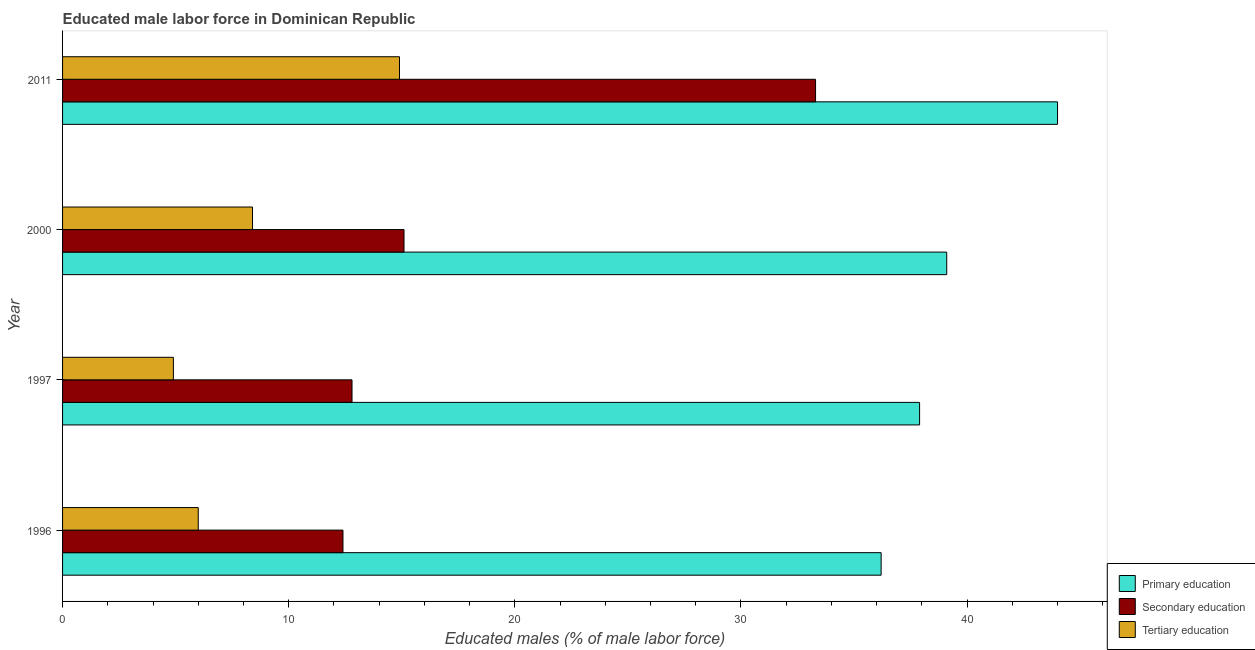How many bars are there on the 1st tick from the top?
Make the answer very short. 3. How many bars are there on the 2nd tick from the bottom?
Offer a terse response. 3. What is the label of the 4th group of bars from the top?
Give a very brief answer. 1996. What is the percentage of male labor force who received primary education in 2011?
Provide a succinct answer. 44. Across all years, what is the minimum percentage of male labor force who received tertiary education?
Ensure brevity in your answer.  4.9. In which year was the percentage of male labor force who received secondary education maximum?
Ensure brevity in your answer.  2011. What is the total percentage of male labor force who received tertiary education in the graph?
Offer a terse response. 34.2. What is the difference between the percentage of male labor force who received secondary education in 1996 and that in 1997?
Provide a succinct answer. -0.4. What is the difference between the percentage of male labor force who received primary education in 1997 and the percentage of male labor force who received tertiary education in 2011?
Provide a short and direct response. 23. In the year 2011, what is the difference between the percentage of male labor force who received secondary education and percentage of male labor force who received primary education?
Your answer should be compact. -10.7. In how many years, is the percentage of male labor force who received primary education greater than 8 %?
Provide a short and direct response. 4. What is the ratio of the percentage of male labor force who received secondary education in 1996 to that in 2011?
Your answer should be compact. 0.37. Is the percentage of male labor force who received primary education in 1996 less than that in 2011?
Your response must be concise. Yes. Is the difference between the percentage of male labor force who received primary education in 1997 and 2000 greater than the difference between the percentage of male labor force who received secondary education in 1997 and 2000?
Give a very brief answer. Yes. What is the difference between the highest and the lowest percentage of male labor force who received tertiary education?
Your response must be concise. 10. In how many years, is the percentage of male labor force who received primary education greater than the average percentage of male labor force who received primary education taken over all years?
Your response must be concise. 1. What does the 3rd bar from the top in 2011 represents?
Offer a very short reply. Primary education. What does the 3rd bar from the bottom in 1997 represents?
Offer a terse response. Tertiary education. How many years are there in the graph?
Provide a succinct answer. 4. What is the difference between two consecutive major ticks on the X-axis?
Your answer should be very brief. 10. Does the graph contain any zero values?
Provide a succinct answer. No. How are the legend labels stacked?
Offer a terse response. Vertical. What is the title of the graph?
Provide a short and direct response. Educated male labor force in Dominican Republic. What is the label or title of the X-axis?
Provide a short and direct response. Educated males (% of male labor force). What is the label or title of the Y-axis?
Give a very brief answer. Year. What is the Educated males (% of male labor force) of Primary education in 1996?
Give a very brief answer. 36.2. What is the Educated males (% of male labor force) in Secondary education in 1996?
Your answer should be compact. 12.4. What is the Educated males (% of male labor force) of Primary education in 1997?
Provide a short and direct response. 37.9. What is the Educated males (% of male labor force) of Secondary education in 1997?
Your answer should be very brief. 12.8. What is the Educated males (% of male labor force) of Tertiary education in 1997?
Offer a terse response. 4.9. What is the Educated males (% of male labor force) of Primary education in 2000?
Your answer should be very brief. 39.1. What is the Educated males (% of male labor force) in Secondary education in 2000?
Provide a short and direct response. 15.1. What is the Educated males (% of male labor force) of Tertiary education in 2000?
Provide a short and direct response. 8.4. What is the Educated males (% of male labor force) of Primary education in 2011?
Your answer should be compact. 44. What is the Educated males (% of male labor force) of Secondary education in 2011?
Your response must be concise. 33.3. What is the Educated males (% of male labor force) of Tertiary education in 2011?
Make the answer very short. 14.9. Across all years, what is the maximum Educated males (% of male labor force) of Primary education?
Your response must be concise. 44. Across all years, what is the maximum Educated males (% of male labor force) in Secondary education?
Your answer should be compact. 33.3. Across all years, what is the maximum Educated males (% of male labor force) in Tertiary education?
Your response must be concise. 14.9. Across all years, what is the minimum Educated males (% of male labor force) of Primary education?
Give a very brief answer. 36.2. Across all years, what is the minimum Educated males (% of male labor force) of Secondary education?
Provide a succinct answer. 12.4. Across all years, what is the minimum Educated males (% of male labor force) in Tertiary education?
Provide a succinct answer. 4.9. What is the total Educated males (% of male labor force) in Primary education in the graph?
Make the answer very short. 157.2. What is the total Educated males (% of male labor force) of Secondary education in the graph?
Provide a succinct answer. 73.6. What is the total Educated males (% of male labor force) of Tertiary education in the graph?
Offer a very short reply. 34.2. What is the difference between the Educated males (% of male labor force) in Secondary education in 1996 and that in 1997?
Your answer should be very brief. -0.4. What is the difference between the Educated males (% of male labor force) in Tertiary education in 1996 and that in 1997?
Offer a terse response. 1.1. What is the difference between the Educated males (% of male labor force) in Tertiary education in 1996 and that in 2000?
Offer a terse response. -2.4. What is the difference between the Educated males (% of male labor force) in Primary education in 1996 and that in 2011?
Keep it short and to the point. -7.8. What is the difference between the Educated males (% of male labor force) of Secondary education in 1996 and that in 2011?
Ensure brevity in your answer.  -20.9. What is the difference between the Educated males (% of male labor force) of Tertiary education in 1996 and that in 2011?
Provide a short and direct response. -8.9. What is the difference between the Educated males (% of male labor force) in Secondary education in 1997 and that in 2000?
Ensure brevity in your answer.  -2.3. What is the difference between the Educated males (% of male labor force) in Primary education in 1997 and that in 2011?
Offer a terse response. -6.1. What is the difference between the Educated males (% of male labor force) of Secondary education in 1997 and that in 2011?
Your response must be concise. -20.5. What is the difference between the Educated males (% of male labor force) in Secondary education in 2000 and that in 2011?
Your response must be concise. -18.2. What is the difference between the Educated males (% of male labor force) of Primary education in 1996 and the Educated males (% of male labor force) of Secondary education in 1997?
Make the answer very short. 23.4. What is the difference between the Educated males (% of male labor force) of Primary education in 1996 and the Educated males (% of male labor force) of Tertiary education in 1997?
Make the answer very short. 31.3. What is the difference between the Educated males (% of male labor force) in Secondary education in 1996 and the Educated males (% of male labor force) in Tertiary education in 1997?
Your answer should be very brief. 7.5. What is the difference between the Educated males (% of male labor force) in Primary education in 1996 and the Educated males (% of male labor force) in Secondary education in 2000?
Offer a very short reply. 21.1. What is the difference between the Educated males (% of male labor force) of Primary education in 1996 and the Educated males (% of male labor force) of Tertiary education in 2000?
Your answer should be very brief. 27.8. What is the difference between the Educated males (% of male labor force) in Secondary education in 1996 and the Educated males (% of male labor force) in Tertiary education in 2000?
Your answer should be very brief. 4. What is the difference between the Educated males (% of male labor force) of Primary education in 1996 and the Educated males (% of male labor force) of Secondary education in 2011?
Provide a short and direct response. 2.9. What is the difference between the Educated males (% of male labor force) in Primary education in 1996 and the Educated males (% of male labor force) in Tertiary education in 2011?
Offer a very short reply. 21.3. What is the difference between the Educated males (% of male labor force) in Primary education in 1997 and the Educated males (% of male labor force) in Secondary education in 2000?
Your answer should be compact. 22.8. What is the difference between the Educated males (% of male labor force) of Primary education in 1997 and the Educated males (% of male labor force) of Tertiary education in 2000?
Your answer should be compact. 29.5. What is the difference between the Educated males (% of male labor force) of Primary education in 1997 and the Educated males (% of male labor force) of Secondary education in 2011?
Ensure brevity in your answer.  4.6. What is the difference between the Educated males (% of male labor force) in Secondary education in 1997 and the Educated males (% of male labor force) in Tertiary education in 2011?
Provide a short and direct response. -2.1. What is the difference between the Educated males (% of male labor force) of Primary education in 2000 and the Educated males (% of male labor force) of Secondary education in 2011?
Provide a succinct answer. 5.8. What is the difference between the Educated males (% of male labor force) in Primary education in 2000 and the Educated males (% of male labor force) in Tertiary education in 2011?
Make the answer very short. 24.2. What is the difference between the Educated males (% of male labor force) of Secondary education in 2000 and the Educated males (% of male labor force) of Tertiary education in 2011?
Keep it short and to the point. 0.2. What is the average Educated males (% of male labor force) in Primary education per year?
Your response must be concise. 39.3. What is the average Educated males (% of male labor force) in Tertiary education per year?
Offer a very short reply. 8.55. In the year 1996, what is the difference between the Educated males (% of male labor force) of Primary education and Educated males (% of male labor force) of Secondary education?
Your answer should be very brief. 23.8. In the year 1996, what is the difference between the Educated males (% of male labor force) in Primary education and Educated males (% of male labor force) in Tertiary education?
Your response must be concise. 30.2. In the year 1996, what is the difference between the Educated males (% of male labor force) in Secondary education and Educated males (% of male labor force) in Tertiary education?
Keep it short and to the point. 6.4. In the year 1997, what is the difference between the Educated males (% of male labor force) of Primary education and Educated males (% of male labor force) of Secondary education?
Your answer should be very brief. 25.1. In the year 1997, what is the difference between the Educated males (% of male labor force) in Primary education and Educated males (% of male labor force) in Tertiary education?
Your answer should be very brief. 33. In the year 2000, what is the difference between the Educated males (% of male labor force) of Primary education and Educated males (% of male labor force) of Tertiary education?
Keep it short and to the point. 30.7. In the year 2011, what is the difference between the Educated males (% of male labor force) of Primary education and Educated males (% of male labor force) of Secondary education?
Make the answer very short. 10.7. In the year 2011, what is the difference between the Educated males (% of male labor force) of Primary education and Educated males (% of male labor force) of Tertiary education?
Keep it short and to the point. 29.1. In the year 2011, what is the difference between the Educated males (% of male labor force) of Secondary education and Educated males (% of male labor force) of Tertiary education?
Keep it short and to the point. 18.4. What is the ratio of the Educated males (% of male labor force) of Primary education in 1996 to that in 1997?
Offer a very short reply. 0.96. What is the ratio of the Educated males (% of male labor force) in Secondary education in 1996 to that in 1997?
Offer a very short reply. 0.97. What is the ratio of the Educated males (% of male labor force) of Tertiary education in 1996 to that in 1997?
Provide a succinct answer. 1.22. What is the ratio of the Educated males (% of male labor force) of Primary education in 1996 to that in 2000?
Ensure brevity in your answer.  0.93. What is the ratio of the Educated males (% of male labor force) of Secondary education in 1996 to that in 2000?
Offer a very short reply. 0.82. What is the ratio of the Educated males (% of male labor force) in Tertiary education in 1996 to that in 2000?
Provide a succinct answer. 0.71. What is the ratio of the Educated males (% of male labor force) of Primary education in 1996 to that in 2011?
Give a very brief answer. 0.82. What is the ratio of the Educated males (% of male labor force) in Secondary education in 1996 to that in 2011?
Make the answer very short. 0.37. What is the ratio of the Educated males (% of male labor force) in Tertiary education in 1996 to that in 2011?
Your answer should be very brief. 0.4. What is the ratio of the Educated males (% of male labor force) of Primary education in 1997 to that in 2000?
Offer a very short reply. 0.97. What is the ratio of the Educated males (% of male labor force) in Secondary education in 1997 to that in 2000?
Offer a terse response. 0.85. What is the ratio of the Educated males (% of male labor force) of Tertiary education in 1997 to that in 2000?
Provide a succinct answer. 0.58. What is the ratio of the Educated males (% of male labor force) in Primary education in 1997 to that in 2011?
Your answer should be very brief. 0.86. What is the ratio of the Educated males (% of male labor force) in Secondary education in 1997 to that in 2011?
Provide a succinct answer. 0.38. What is the ratio of the Educated males (% of male labor force) in Tertiary education in 1997 to that in 2011?
Offer a terse response. 0.33. What is the ratio of the Educated males (% of male labor force) of Primary education in 2000 to that in 2011?
Your response must be concise. 0.89. What is the ratio of the Educated males (% of male labor force) of Secondary education in 2000 to that in 2011?
Keep it short and to the point. 0.45. What is the ratio of the Educated males (% of male labor force) of Tertiary education in 2000 to that in 2011?
Give a very brief answer. 0.56. What is the difference between the highest and the second highest Educated males (% of male labor force) of Tertiary education?
Offer a terse response. 6.5. What is the difference between the highest and the lowest Educated males (% of male labor force) of Secondary education?
Your answer should be very brief. 20.9. What is the difference between the highest and the lowest Educated males (% of male labor force) in Tertiary education?
Your response must be concise. 10. 